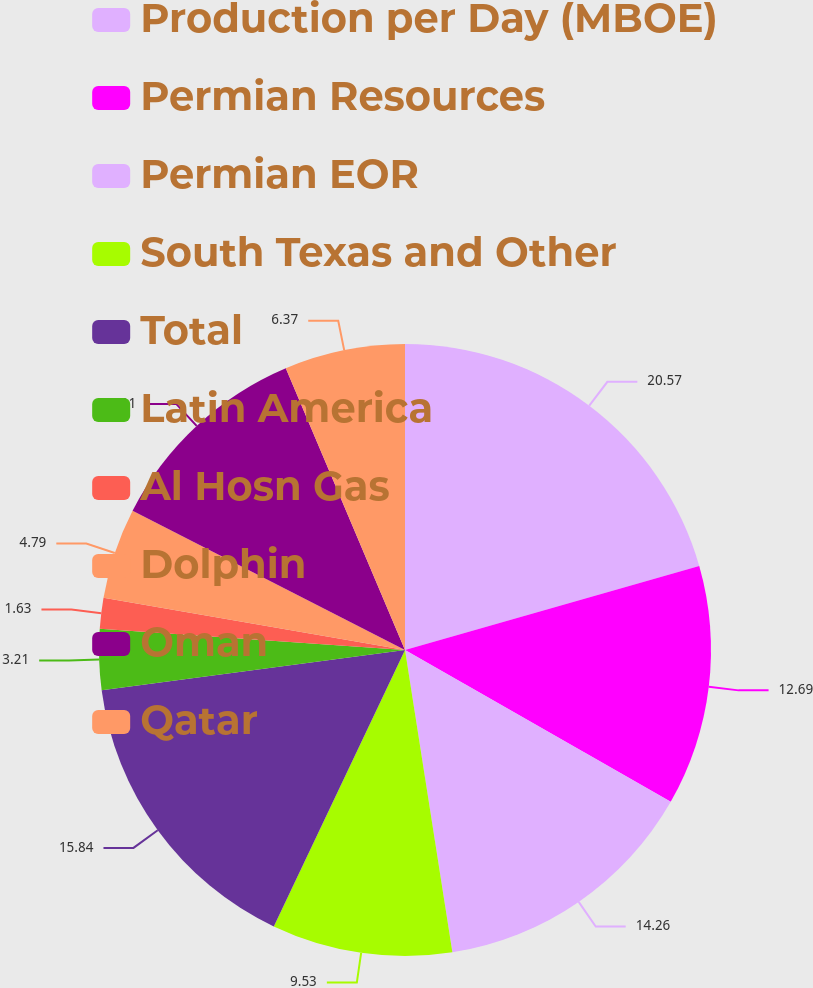Convert chart. <chart><loc_0><loc_0><loc_500><loc_500><pie_chart><fcel>Production per Day (MBOE)<fcel>Permian Resources<fcel>Permian EOR<fcel>South Texas and Other<fcel>Total<fcel>Latin America<fcel>Al Hosn Gas<fcel>Dolphin<fcel>Oman<fcel>Qatar<nl><fcel>20.58%<fcel>12.69%<fcel>14.27%<fcel>9.53%<fcel>15.85%<fcel>3.21%<fcel>1.63%<fcel>4.79%<fcel>11.11%<fcel>6.37%<nl></chart> 